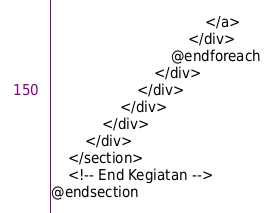<code> <loc_0><loc_0><loc_500><loc_500><_PHP_>                                    </a>
                                </div>
                            @endforeach
                        </div>
                    </div>
                </div>
            </div>
        </div>
    </section>
    <!-- End Kegiatan -->
@endsection</code> 